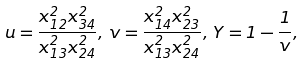<formula> <loc_0><loc_0><loc_500><loc_500>u = \frac { x _ { 1 2 } ^ { 2 } x _ { 3 4 } ^ { 2 } } { x _ { 1 3 } ^ { 2 } x _ { 2 4 } ^ { 2 } } , \, v = \frac { x _ { 1 4 } ^ { 2 } x _ { 2 3 } ^ { 2 } } { x _ { 1 3 } ^ { 2 } x _ { 2 4 } ^ { 2 } } , \, Y = 1 - \frac { 1 } { v } ,</formula> 